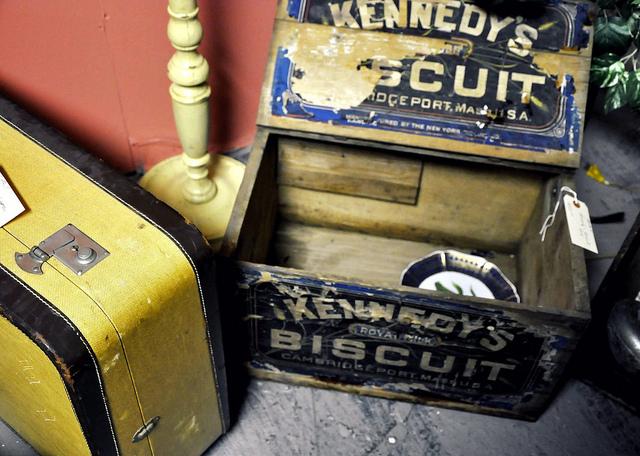What color is the briefcase?
Write a very short answer. Yellow. Are these items antique?
Be succinct. Yes. Are these briefcases in good shape?
Answer briefly. No. 